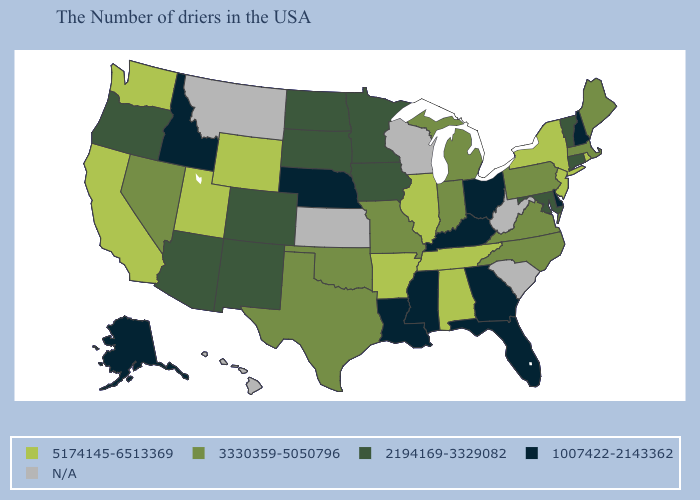Name the states that have a value in the range N/A?
Be succinct. South Carolina, West Virginia, Wisconsin, Kansas, Montana, Hawaii. Name the states that have a value in the range 2194169-3329082?
Give a very brief answer. Vermont, Connecticut, Maryland, Minnesota, Iowa, South Dakota, North Dakota, Colorado, New Mexico, Arizona, Oregon. What is the value of New York?
Quick response, please. 5174145-6513369. Which states have the lowest value in the USA?
Quick response, please. New Hampshire, Delaware, Ohio, Florida, Georgia, Kentucky, Mississippi, Louisiana, Nebraska, Idaho, Alaska. What is the lowest value in states that border Missouri?
Keep it brief. 1007422-2143362. Name the states that have a value in the range 3330359-5050796?
Answer briefly. Maine, Massachusetts, Pennsylvania, Virginia, North Carolina, Michigan, Indiana, Missouri, Oklahoma, Texas, Nevada. What is the value of Tennessee?
Short answer required. 5174145-6513369. Does Alaska have the highest value in the USA?
Write a very short answer. No. Name the states that have a value in the range 5174145-6513369?
Be succinct. Rhode Island, New York, New Jersey, Alabama, Tennessee, Illinois, Arkansas, Wyoming, Utah, California, Washington. Does the first symbol in the legend represent the smallest category?
Give a very brief answer. No. What is the lowest value in the USA?
Quick response, please. 1007422-2143362. Name the states that have a value in the range N/A?
Give a very brief answer. South Carolina, West Virginia, Wisconsin, Kansas, Montana, Hawaii. Does the map have missing data?
Keep it brief. Yes. How many symbols are there in the legend?
Keep it brief. 5. What is the value of South Dakota?
Be succinct. 2194169-3329082. 